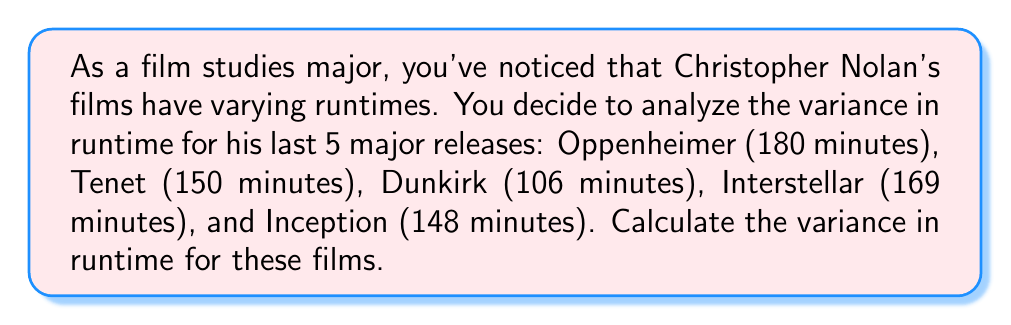Teach me how to tackle this problem. To calculate the variance, we'll follow these steps:

1. Calculate the mean runtime:
   $\mu = \frac{180 + 150 + 106 + 169 + 148}{5} = 150.6$ minutes

2. Calculate the squared differences from the mean:
   $(180 - 150.6)^2 = 864.16$
   $(150 - 150.6)^2 = 0.36$
   $(106 - 150.6)^2 = 1989.16$
   $(169 - 150.6)^2 = 338.56$
   $(148 - 150.6)^2 = 6.76$

3. Sum the squared differences:
   $864.16 + 0.36 + 1989.16 + 338.56 + 6.76 = 3199$

4. Divide by the number of films (5) to get the variance:
   $$\text{Variance} = \frac{3199}{5} = 639.8$$

Therefore, the variance in runtime for these Christopher Nolan films is 639.8 square minutes.
Answer: 639.8 square minutes 